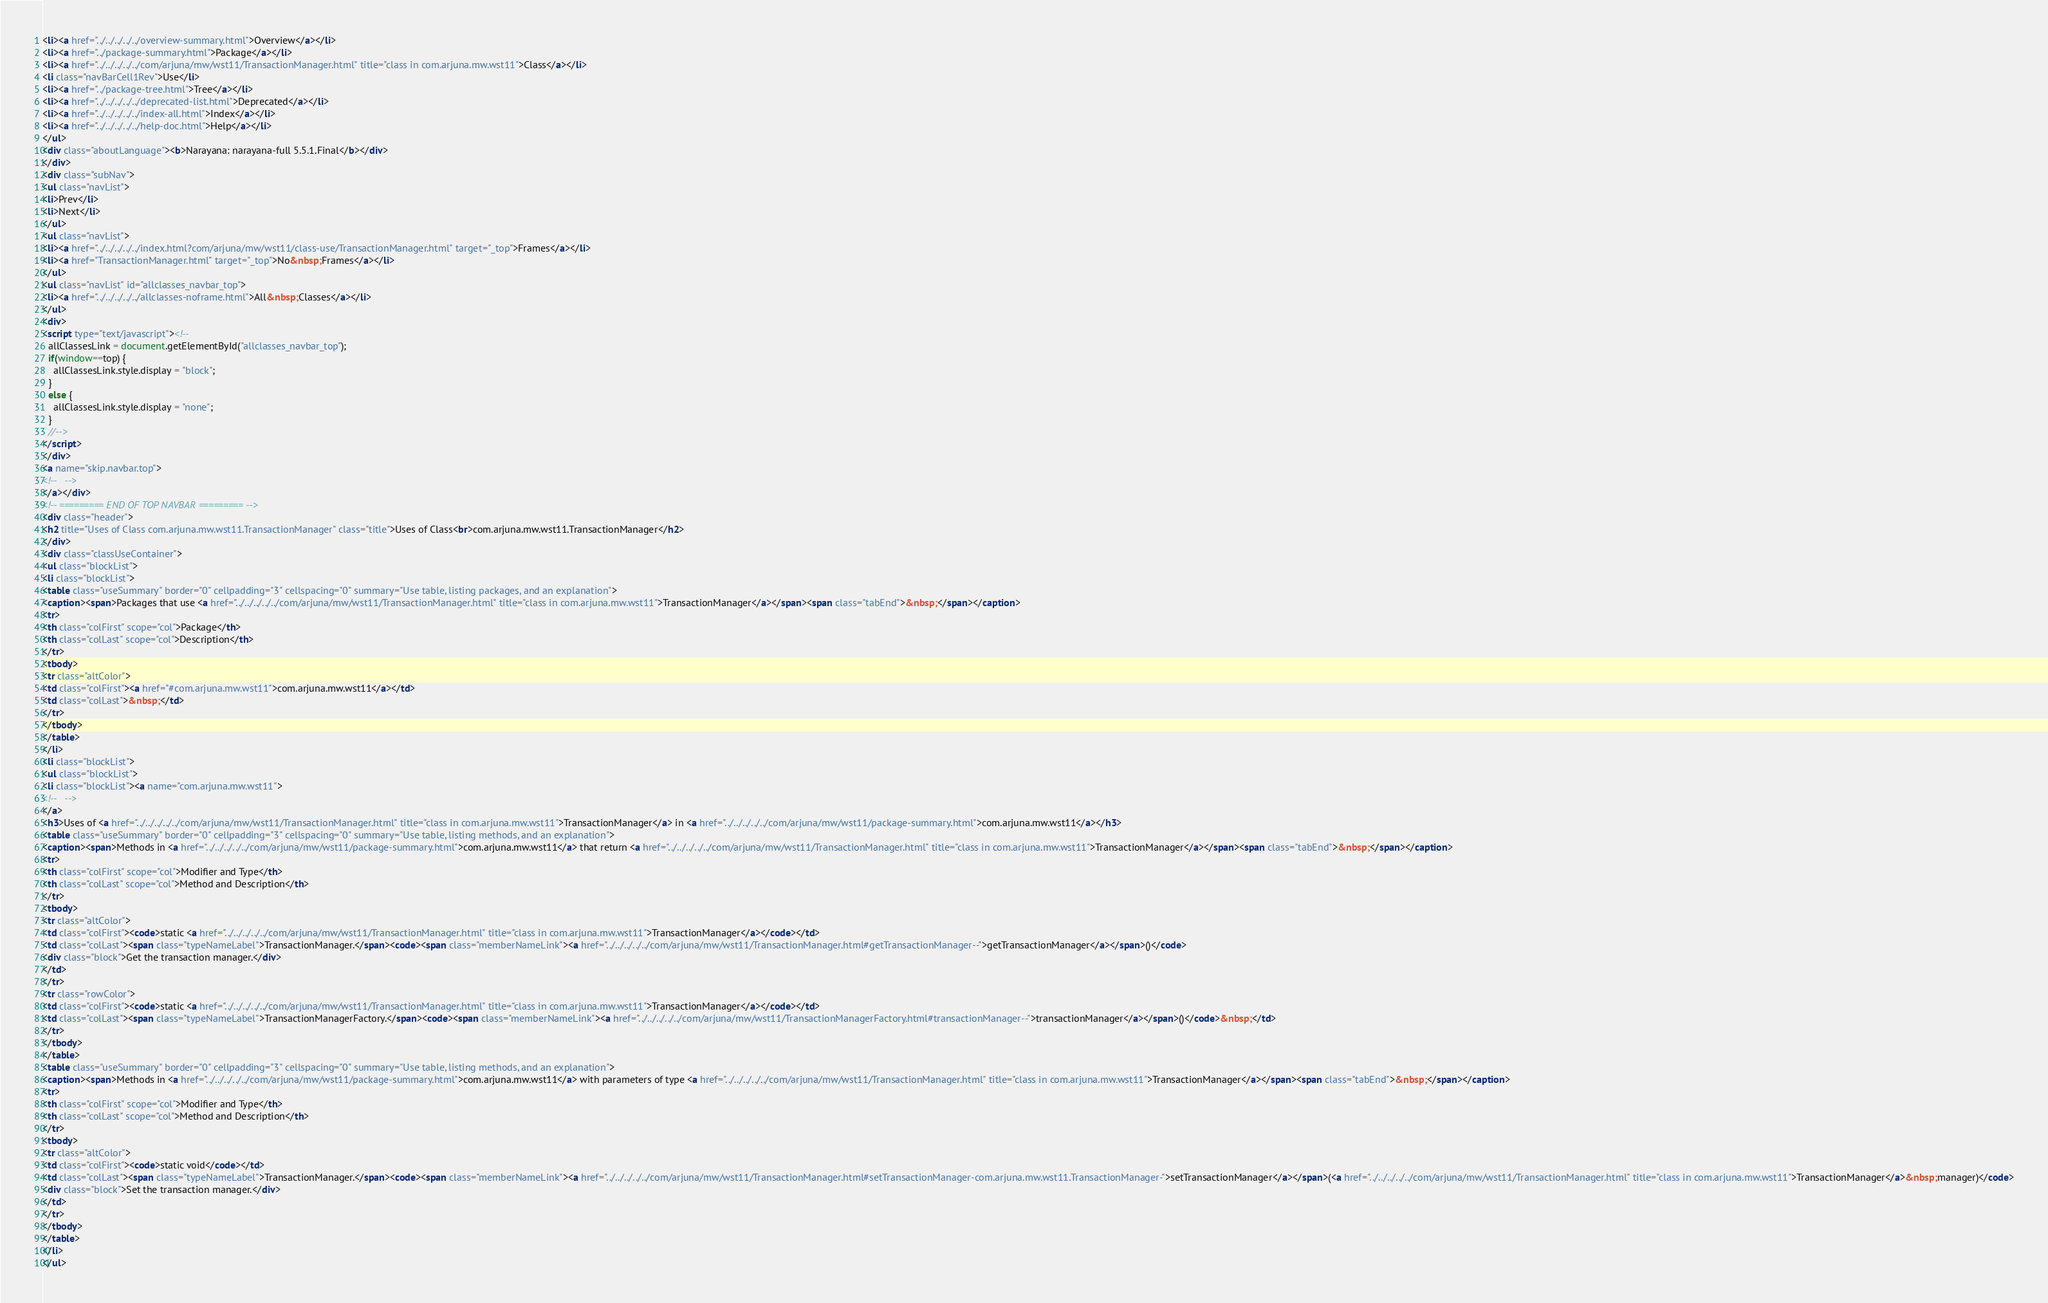Convert code to text. <code><loc_0><loc_0><loc_500><loc_500><_HTML_><li><a href="../../../../../overview-summary.html">Overview</a></li>
<li><a href="../package-summary.html">Package</a></li>
<li><a href="../../../../../com/arjuna/mw/wst11/TransactionManager.html" title="class in com.arjuna.mw.wst11">Class</a></li>
<li class="navBarCell1Rev">Use</li>
<li><a href="../package-tree.html">Tree</a></li>
<li><a href="../../../../../deprecated-list.html">Deprecated</a></li>
<li><a href="../../../../../index-all.html">Index</a></li>
<li><a href="../../../../../help-doc.html">Help</a></li>
</ul>
<div class="aboutLanguage"><b>Narayana: narayana-full 5.5.1.Final</b></div>
</div>
<div class="subNav">
<ul class="navList">
<li>Prev</li>
<li>Next</li>
</ul>
<ul class="navList">
<li><a href="../../../../../index.html?com/arjuna/mw/wst11/class-use/TransactionManager.html" target="_top">Frames</a></li>
<li><a href="TransactionManager.html" target="_top">No&nbsp;Frames</a></li>
</ul>
<ul class="navList" id="allclasses_navbar_top">
<li><a href="../../../../../allclasses-noframe.html">All&nbsp;Classes</a></li>
</ul>
<div>
<script type="text/javascript"><!--
  allClassesLink = document.getElementById("allclasses_navbar_top");
  if(window==top) {
    allClassesLink.style.display = "block";
  }
  else {
    allClassesLink.style.display = "none";
  }
  //-->
</script>
</div>
<a name="skip.navbar.top">
<!--   -->
</a></div>
<!-- ========= END OF TOP NAVBAR ========= -->
<div class="header">
<h2 title="Uses of Class com.arjuna.mw.wst11.TransactionManager" class="title">Uses of Class<br>com.arjuna.mw.wst11.TransactionManager</h2>
</div>
<div class="classUseContainer">
<ul class="blockList">
<li class="blockList">
<table class="useSummary" border="0" cellpadding="3" cellspacing="0" summary="Use table, listing packages, and an explanation">
<caption><span>Packages that use <a href="../../../../../com/arjuna/mw/wst11/TransactionManager.html" title="class in com.arjuna.mw.wst11">TransactionManager</a></span><span class="tabEnd">&nbsp;</span></caption>
<tr>
<th class="colFirst" scope="col">Package</th>
<th class="colLast" scope="col">Description</th>
</tr>
<tbody>
<tr class="altColor">
<td class="colFirst"><a href="#com.arjuna.mw.wst11">com.arjuna.mw.wst11</a></td>
<td class="colLast">&nbsp;</td>
</tr>
</tbody>
</table>
</li>
<li class="blockList">
<ul class="blockList">
<li class="blockList"><a name="com.arjuna.mw.wst11">
<!--   -->
</a>
<h3>Uses of <a href="../../../../../com/arjuna/mw/wst11/TransactionManager.html" title="class in com.arjuna.mw.wst11">TransactionManager</a> in <a href="../../../../../com/arjuna/mw/wst11/package-summary.html">com.arjuna.mw.wst11</a></h3>
<table class="useSummary" border="0" cellpadding="3" cellspacing="0" summary="Use table, listing methods, and an explanation">
<caption><span>Methods in <a href="../../../../../com/arjuna/mw/wst11/package-summary.html">com.arjuna.mw.wst11</a> that return <a href="../../../../../com/arjuna/mw/wst11/TransactionManager.html" title="class in com.arjuna.mw.wst11">TransactionManager</a></span><span class="tabEnd">&nbsp;</span></caption>
<tr>
<th class="colFirst" scope="col">Modifier and Type</th>
<th class="colLast" scope="col">Method and Description</th>
</tr>
<tbody>
<tr class="altColor">
<td class="colFirst"><code>static <a href="../../../../../com/arjuna/mw/wst11/TransactionManager.html" title="class in com.arjuna.mw.wst11">TransactionManager</a></code></td>
<td class="colLast"><span class="typeNameLabel">TransactionManager.</span><code><span class="memberNameLink"><a href="../../../../../com/arjuna/mw/wst11/TransactionManager.html#getTransactionManager--">getTransactionManager</a></span>()</code>
<div class="block">Get the transaction manager.</div>
</td>
</tr>
<tr class="rowColor">
<td class="colFirst"><code>static <a href="../../../../../com/arjuna/mw/wst11/TransactionManager.html" title="class in com.arjuna.mw.wst11">TransactionManager</a></code></td>
<td class="colLast"><span class="typeNameLabel">TransactionManagerFactory.</span><code><span class="memberNameLink"><a href="../../../../../com/arjuna/mw/wst11/TransactionManagerFactory.html#transactionManager--">transactionManager</a></span>()</code>&nbsp;</td>
</tr>
</tbody>
</table>
<table class="useSummary" border="0" cellpadding="3" cellspacing="0" summary="Use table, listing methods, and an explanation">
<caption><span>Methods in <a href="../../../../../com/arjuna/mw/wst11/package-summary.html">com.arjuna.mw.wst11</a> with parameters of type <a href="../../../../../com/arjuna/mw/wst11/TransactionManager.html" title="class in com.arjuna.mw.wst11">TransactionManager</a></span><span class="tabEnd">&nbsp;</span></caption>
<tr>
<th class="colFirst" scope="col">Modifier and Type</th>
<th class="colLast" scope="col">Method and Description</th>
</tr>
<tbody>
<tr class="altColor">
<td class="colFirst"><code>static void</code></td>
<td class="colLast"><span class="typeNameLabel">TransactionManager.</span><code><span class="memberNameLink"><a href="../../../../../com/arjuna/mw/wst11/TransactionManager.html#setTransactionManager-com.arjuna.mw.wst11.TransactionManager-">setTransactionManager</a></span>(<a href="../../../../../com/arjuna/mw/wst11/TransactionManager.html" title="class in com.arjuna.mw.wst11">TransactionManager</a>&nbsp;manager)</code>
<div class="block">Set the transaction manager.</div>
</td>
</tr>
</tbody>
</table>
</li>
</ul></code> 